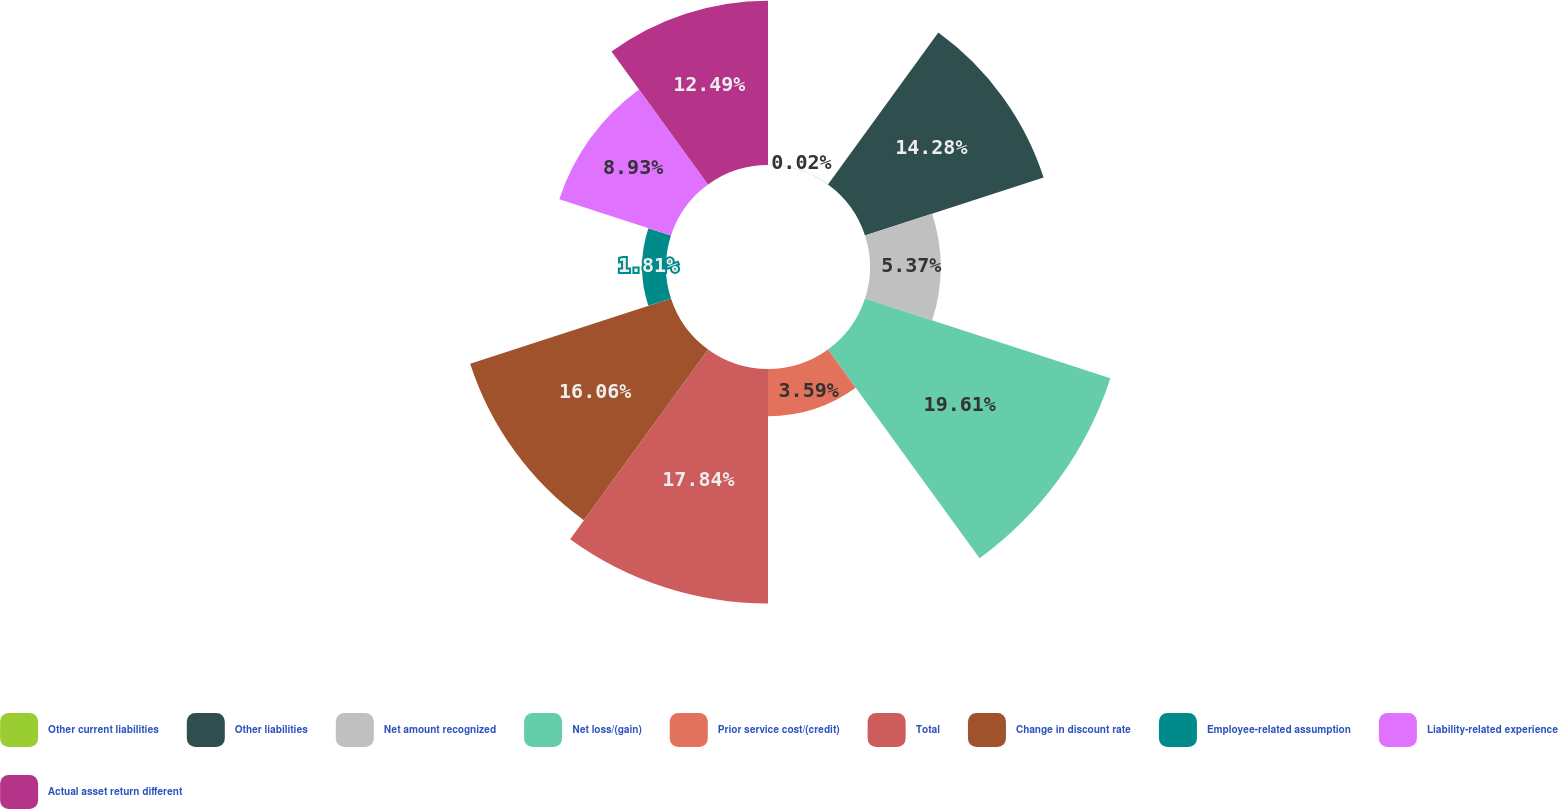Convert chart. <chart><loc_0><loc_0><loc_500><loc_500><pie_chart><fcel>Other current liabilities<fcel>Other liabilities<fcel>Net amount recognized<fcel>Net loss/(gain)<fcel>Prior service cost/(credit)<fcel>Total<fcel>Change in discount rate<fcel>Employee-related assumption<fcel>Liability-related experience<fcel>Actual asset return different<nl><fcel>0.02%<fcel>14.28%<fcel>5.37%<fcel>19.62%<fcel>3.59%<fcel>17.84%<fcel>16.06%<fcel>1.81%<fcel>8.93%<fcel>12.49%<nl></chart> 